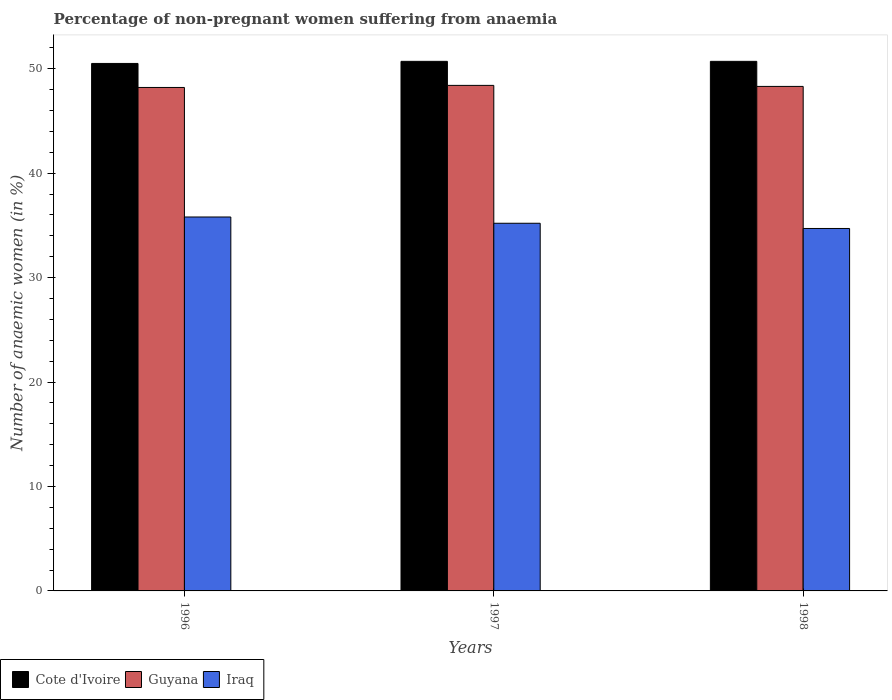How many different coloured bars are there?
Your response must be concise. 3. How many groups of bars are there?
Keep it short and to the point. 3. How many bars are there on the 1st tick from the right?
Ensure brevity in your answer.  3. What is the label of the 2nd group of bars from the left?
Provide a succinct answer. 1997. What is the percentage of non-pregnant women suffering from anaemia in Guyana in 1998?
Make the answer very short. 48.3. Across all years, what is the maximum percentage of non-pregnant women suffering from anaemia in Cote d'Ivoire?
Provide a short and direct response. 50.7. Across all years, what is the minimum percentage of non-pregnant women suffering from anaemia in Cote d'Ivoire?
Provide a short and direct response. 50.5. In which year was the percentage of non-pregnant women suffering from anaemia in Guyana minimum?
Make the answer very short. 1996. What is the total percentage of non-pregnant women suffering from anaemia in Cote d'Ivoire in the graph?
Ensure brevity in your answer.  151.9. What is the difference between the percentage of non-pregnant women suffering from anaemia in Iraq in 1996 and that in 1997?
Ensure brevity in your answer.  0.6. What is the average percentage of non-pregnant women suffering from anaemia in Cote d'Ivoire per year?
Your answer should be very brief. 50.63. In the year 1996, what is the difference between the percentage of non-pregnant women suffering from anaemia in Guyana and percentage of non-pregnant women suffering from anaemia in Iraq?
Make the answer very short. 12.4. What is the ratio of the percentage of non-pregnant women suffering from anaemia in Iraq in 1996 to that in 1997?
Your answer should be very brief. 1.02. Is the percentage of non-pregnant women suffering from anaemia in Cote d'Ivoire in 1996 less than that in 1997?
Give a very brief answer. Yes. What is the difference between the highest and the second highest percentage of non-pregnant women suffering from anaemia in Cote d'Ivoire?
Ensure brevity in your answer.  0. What is the difference between the highest and the lowest percentage of non-pregnant women suffering from anaemia in Iraq?
Your answer should be compact. 1.1. Is the sum of the percentage of non-pregnant women suffering from anaemia in Guyana in 1996 and 1998 greater than the maximum percentage of non-pregnant women suffering from anaemia in Cote d'Ivoire across all years?
Your answer should be very brief. Yes. What does the 1st bar from the left in 1996 represents?
Keep it short and to the point. Cote d'Ivoire. What does the 3rd bar from the right in 1996 represents?
Keep it short and to the point. Cote d'Ivoire. Is it the case that in every year, the sum of the percentage of non-pregnant women suffering from anaemia in Cote d'Ivoire and percentage of non-pregnant women suffering from anaemia in Iraq is greater than the percentage of non-pregnant women suffering from anaemia in Guyana?
Ensure brevity in your answer.  Yes. Are all the bars in the graph horizontal?
Give a very brief answer. No. What is the title of the graph?
Your answer should be very brief. Percentage of non-pregnant women suffering from anaemia. Does "Saudi Arabia" appear as one of the legend labels in the graph?
Ensure brevity in your answer.  No. What is the label or title of the X-axis?
Offer a very short reply. Years. What is the label or title of the Y-axis?
Ensure brevity in your answer.  Number of anaemic women (in %). What is the Number of anaemic women (in %) of Cote d'Ivoire in 1996?
Your answer should be compact. 50.5. What is the Number of anaemic women (in %) of Guyana in 1996?
Ensure brevity in your answer.  48.2. What is the Number of anaemic women (in %) in Iraq in 1996?
Provide a short and direct response. 35.8. What is the Number of anaemic women (in %) of Cote d'Ivoire in 1997?
Your answer should be compact. 50.7. What is the Number of anaemic women (in %) in Guyana in 1997?
Offer a terse response. 48.4. What is the Number of anaemic women (in %) of Iraq in 1997?
Your response must be concise. 35.2. What is the Number of anaemic women (in %) in Cote d'Ivoire in 1998?
Provide a short and direct response. 50.7. What is the Number of anaemic women (in %) in Guyana in 1998?
Your answer should be very brief. 48.3. What is the Number of anaemic women (in %) of Iraq in 1998?
Your answer should be compact. 34.7. Across all years, what is the maximum Number of anaemic women (in %) in Cote d'Ivoire?
Your answer should be very brief. 50.7. Across all years, what is the maximum Number of anaemic women (in %) in Guyana?
Your response must be concise. 48.4. Across all years, what is the maximum Number of anaemic women (in %) in Iraq?
Offer a terse response. 35.8. Across all years, what is the minimum Number of anaemic women (in %) in Cote d'Ivoire?
Give a very brief answer. 50.5. Across all years, what is the minimum Number of anaemic women (in %) of Guyana?
Ensure brevity in your answer.  48.2. Across all years, what is the minimum Number of anaemic women (in %) in Iraq?
Your response must be concise. 34.7. What is the total Number of anaemic women (in %) of Cote d'Ivoire in the graph?
Give a very brief answer. 151.9. What is the total Number of anaemic women (in %) in Guyana in the graph?
Ensure brevity in your answer.  144.9. What is the total Number of anaemic women (in %) of Iraq in the graph?
Give a very brief answer. 105.7. What is the difference between the Number of anaemic women (in %) in Cote d'Ivoire in 1996 and that in 1998?
Provide a succinct answer. -0.2. What is the difference between the Number of anaemic women (in %) of Cote d'Ivoire in 1997 and that in 1998?
Your answer should be compact. 0. What is the difference between the Number of anaemic women (in %) of Guyana in 1997 and that in 1998?
Offer a terse response. 0.1. What is the difference between the Number of anaemic women (in %) in Iraq in 1997 and that in 1998?
Your response must be concise. 0.5. What is the difference between the Number of anaemic women (in %) of Guyana in 1996 and the Number of anaemic women (in %) of Iraq in 1997?
Offer a very short reply. 13. What is the difference between the Number of anaemic women (in %) of Cote d'Ivoire in 1996 and the Number of anaemic women (in %) of Guyana in 1998?
Your answer should be very brief. 2.2. What is the difference between the Number of anaemic women (in %) of Cote d'Ivoire in 1996 and the Number of anaemic women (in %) of Iraq in 1998?
Offer a terse response. 15.8. What is the difference between the Number of anaemic women (in %) in Cote d'Ivoire in 1997 and the Number of anaemic women (in %) in Guyana in 1998?
Give a very brief answer. 2.4. What is the difference between the Number of anaemic women (in %) of Cote d'Ivoire in 1997 and the Number of anaemic women (in %) of Iraq in 1998?
Your response must be concise. 16. What is the difference between the Number of anaemic women (in %) of Guyana in 1997 and the Number of anaemic women (in %) of Iraq in 1998?
Your answer should be compact. 13.7. What is the average Number of anaemic women (in %) of Cote d'Ivoire per year?
Provide a short and direct response. 50.63. What is the average Number of anaemic women (in %) of Guyana per year?
Ensure brevity in your answer.  48.3. What is the average Number of anaemic women (in %) of Iraq per year?
Ensure brevity in your answer.  35.23. In the year 1996, what is the difference between the Number of anaemic women (in %) of Cote d'Ivoire and Number of anaemic women (in %) of Guyana?
Ensure brevity in your answer.  2.3. In the year 1996, what is the difference between the Number of anaemic women (in %) in Guyana and Number of anaemic women (in %) in Iraq?
Make the answer very short. 12.4. In the year 1997, what is the difference between the Number of anaemic women (in %) in Guyana and Number of anaemic women (in %) in Iraq?
Your response must be concise. 13.2. In the year 1998, what is the difference between the Number of anaemic women (in %) of Guyana and Number of anaemic women (in %) of Iraq?
Ensure brevity in your answer.  13.6. What is the ratio of the Number of anaemic women (in %) of Cote d'Ivoire in 1996 to that in 1997?
Give a very brief answer. 1. What is the ratio of the Number of anaemic women (in %) in Guyana in 1996 to that in 1997?
Keep it short and to the point. 1. What is the ratio of the Number of anaemic women (in %) in Guyana in 1996 to that in 1998?
Offer a terse response. 1. What is the ratio of the Number of anaemic women (in %) of Iraq in 1996 to that in 1998?
Provide a succinct answer. 1.03. What is the ratio of the Number of anaemic women (in %) of Guyana in 1997 to that in 1998?
Provide a short and direct response. 1. What is the ratio of the Number of anaemic women (in %) of Iraq in 1997 to that in 1998?
Give a very brief answer. 1.01. What is the difference between the highest and the second highest Number of anaemic women (in %) in Cote d'Ivoire?
Provide a succinct answer. 0. What is the difference between the highest and the lowest Number of anaemic women (in %) in Cote d'Ivoire?
Your answer should be compact. 0.2. What is the difference between the highest and the lowest Number of anaemic women (in %) of Iraq?
Your answer should be very brief. 1.1. 